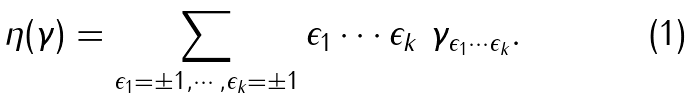<formula> <loc_0><loc_0><loc_500><loc_500>\eta ( \gamma ) = \sum _ { \epsilon _ { 1 } = \pm 1 , \cdots , \epsilon _ { k } = \pm 1 } \epsilon _ { 1 } \cdots \epsilon _ { k } \ \gamma _ { \epsilon _ { 1 } \cdots \epsilon _ { k } } .</formula> 